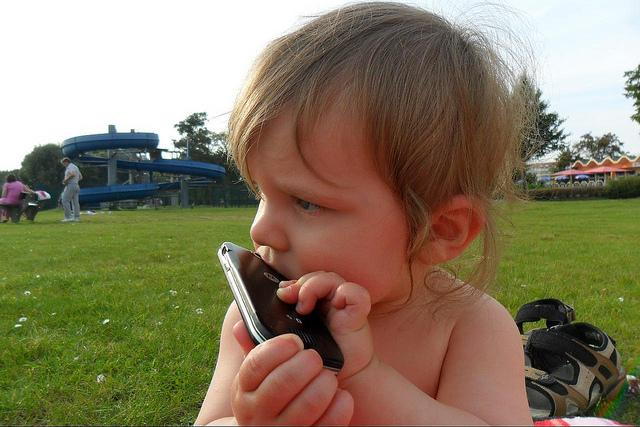What is the baby doing to the phone? chewing 